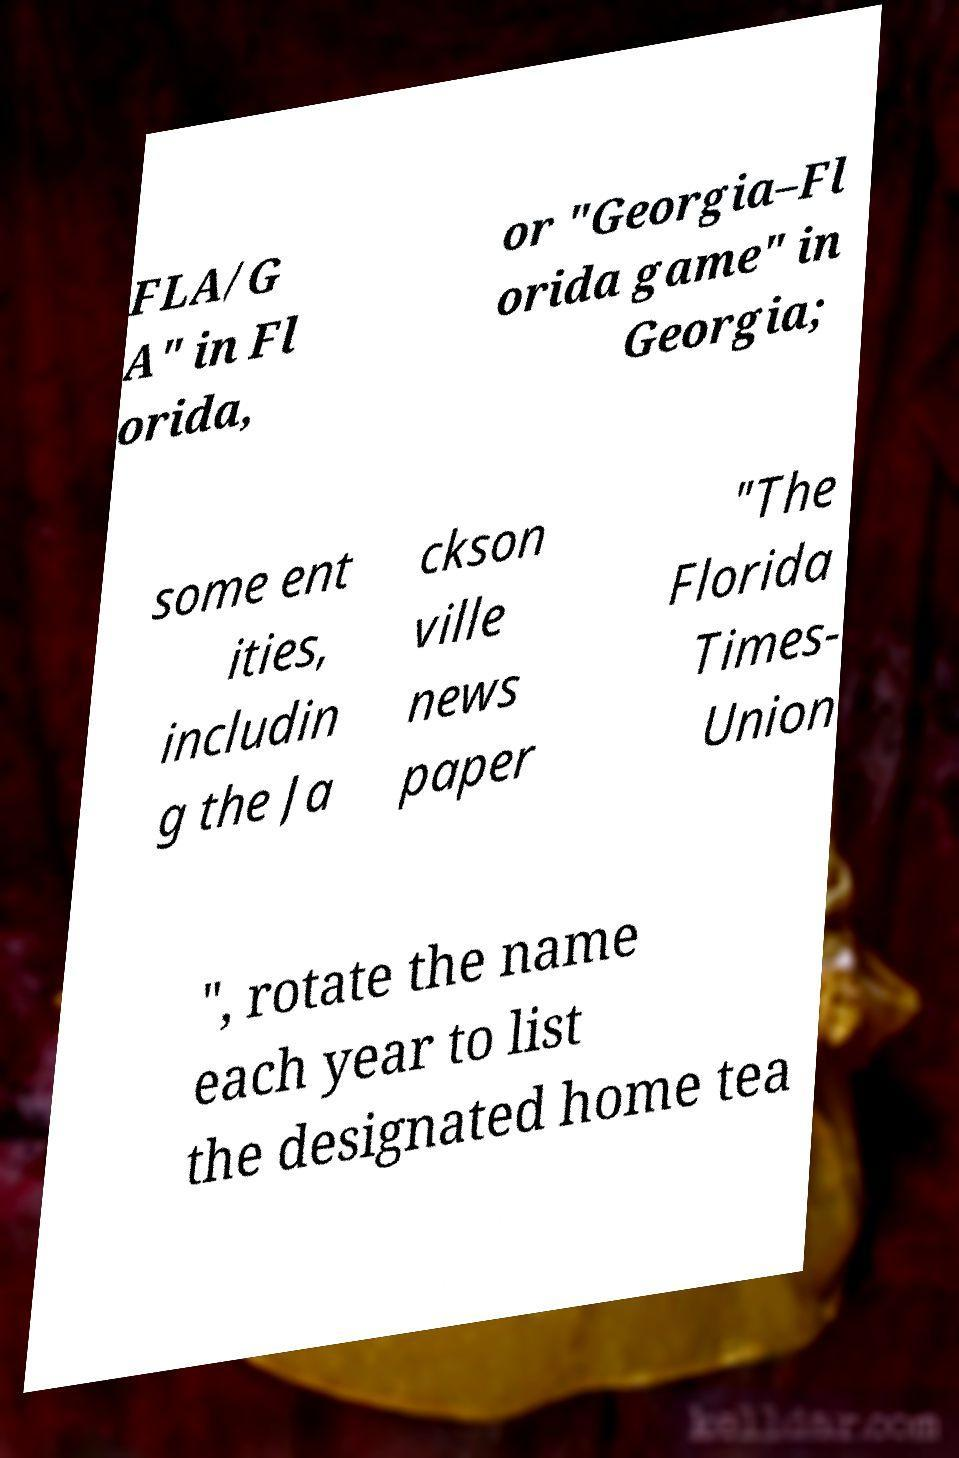Please read and relay the text visible in this image. What does it say? FLA/G A" in Fl orida, or "Georgia–Fl orida game" in Georgia; some ent ities, includin g the Ja ckson ville news paper "The Florida Times- Union ", rotate the name each year to list the designated home tea 